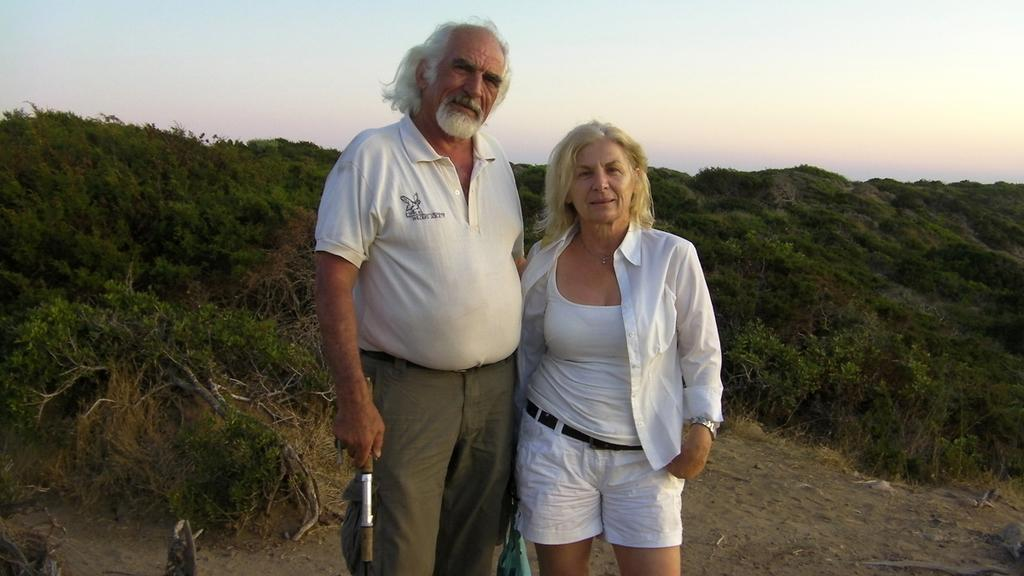How many people are in the image? There are two people in the image. What are the people wearing? The people are wearing white color dresses. What can be seen in the background of the image? There are trees in the background of the image. What is visible at the top of the image? The sky is visible at the top of the image. How many rings can be seen on the father's hand in the image? There is no father present in the image, and therefore no rings can be observed on his hand. 